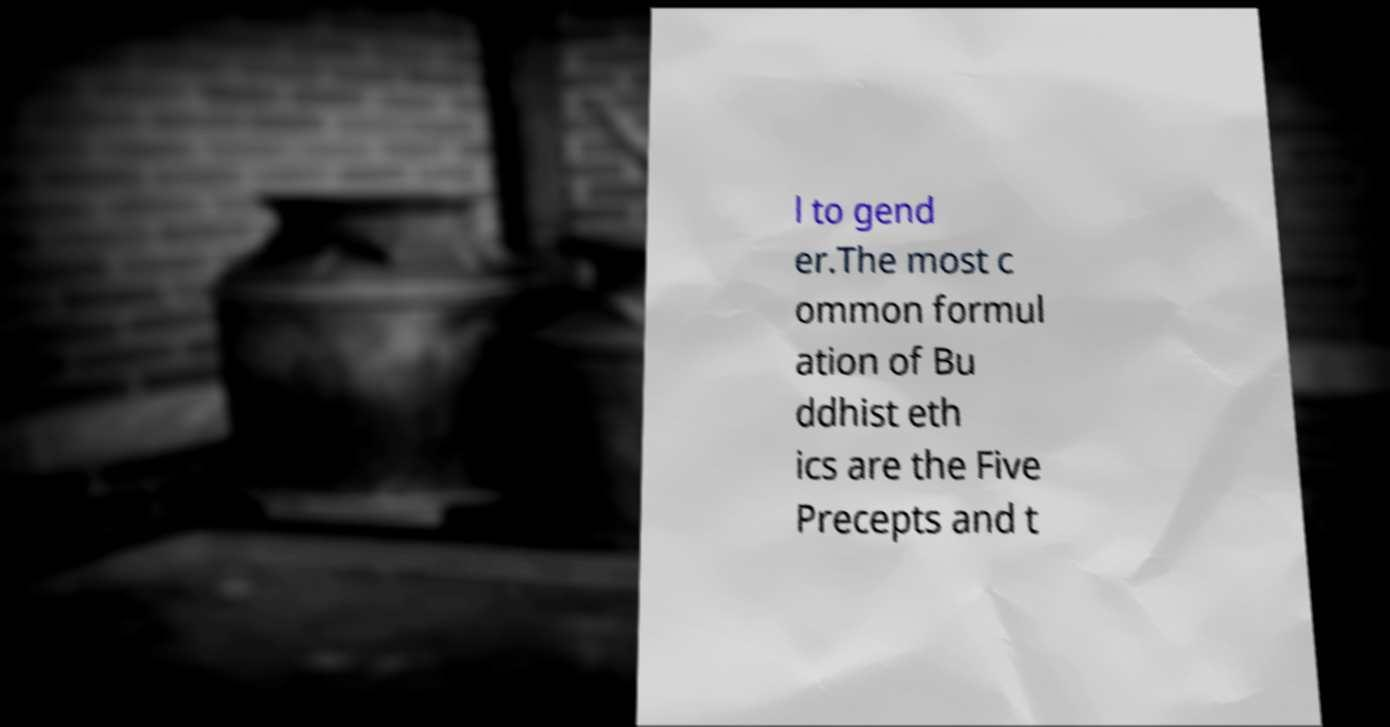What messages or text are displayed in this image? I need them in a readable, typed format. l to gend er.The most c ommon formul ation of Bu ddhist eth ics are the Five Precepts and t 